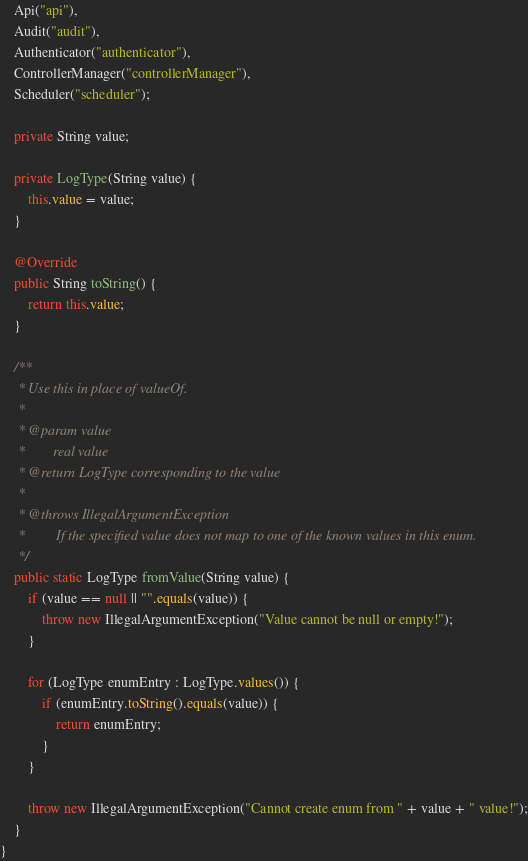<code> <loc_0><loc_0><loc_500><loc_500><_Java_>    Api("api"),
    Audit("audit"),
    Authenticator("authenticator"),
    ControllerManager("controllerManager"),
    Scheduler("scheduler");

    private String value;

    private LogType(String value) {
        this.value = value;
    }

    @Override
    public String toString() {
        return this.value;
    }

    /**
     * Use this in place of valueOf.
     *
     * @param value
     *        real value
     * @return LogType corresponding to the value
     *
     * @throws IllegalArgumentException
     *         If the specified value does not map to one of the known values in this enum.
     */
    public static LogType fromValue(String value) {
        if (value == null || "".equals(value)) {
            throw new IllegalArgumentException("Value cannot be null or empty!");
        }

        for (LogType enumEntry : LogType.values()) {
            if (enumEntry.toString().equals(value)) {
                return enumEntry;
            }
        }

        throw new IllegalArgumentException("Cannot create enum from " + value + " value!");
    }
}
</code> 